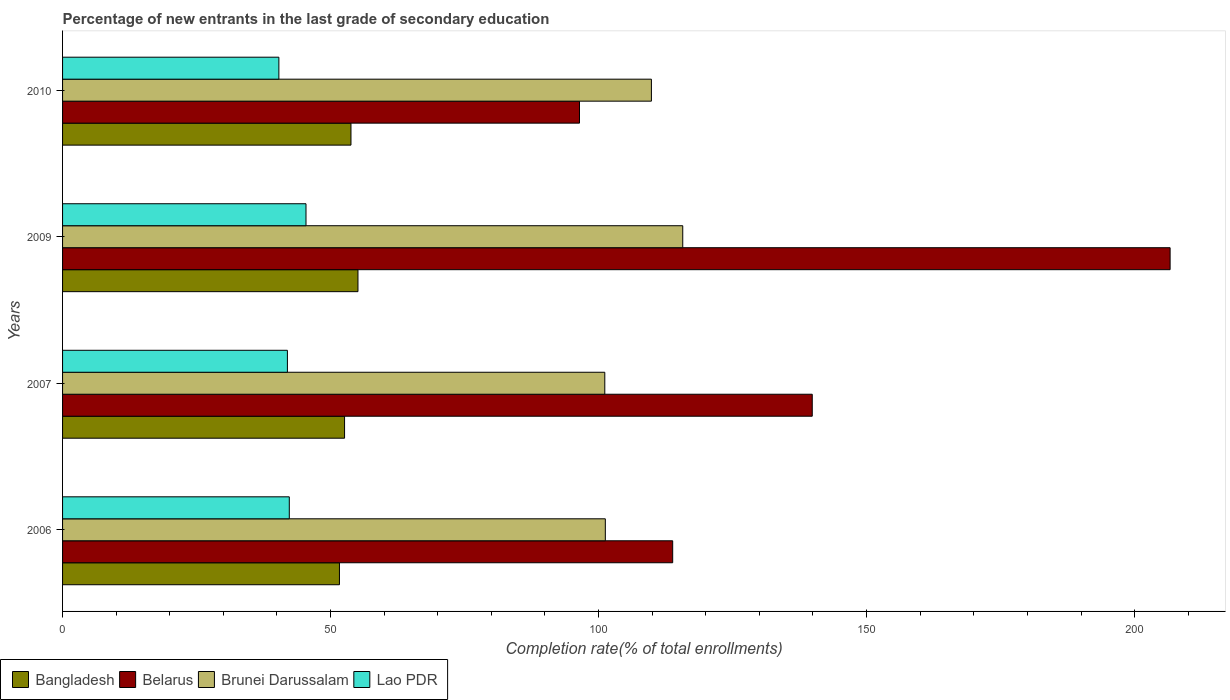Are the number of bars per tick equal to the number of legend labels?
Keep it short and to the point. Yes. What is the label of the 4th group of bars from the top?
Make the answer very short. 2006. What is the percentage of new entrants in Lao PDR in 2009?
Provide a succinct answer. 45.41. Across all years, what is the maximum percentage of new entrants in Belarus?
Provide a short and direct response. 206.63. Across all years, what is the minimum percentage of new entrants in Brunei Darussalam?
Your answer should be compact. 101.16. In which year was the percentage of new entrants in Bangladesh maximum?
Offer a terse response. 2009. In which year was the percentage of new entrants in Lao PDR minimum?
Your answer should be very brief. 2010. What is the total percentage of new entrants in Lao PDR in the graph?
Your answer should be very brief. 170.02. What is the difference between the percentage of new entrants in Bangladesh in 2007 and that in 2010?
Your response must be concise. -1.2. What is the difference between the percentage of new entrants in Brunei Darussalam in 2009 and the percentage of new entrants in Bangladesh in 2007?
Offer a terse response. 63.09. What is the average percentage of new entrants in Lao PDR per year?
Provide a succinct answer. 42.5. In the year 2009, what is the difference between the percentage of new entrants in Lao PDR and percentage of new entrants in Bangladesh?
Your answer should be very brief. -9.7. In how many years, is the percentage of new entrants in Bangladesh greater than 150 %?
Make the answer very short. 0. What is the ratio of the percentage of new entrants in Belarus in 2009 to that in 2010?
Your answer should be very brief. 2.14. Is the percentage of new entrants in Lao PDR in 2007 less than that in 2009?
Your answer should be very brief. Yes. Is the difference between the percentage of new entrants in Lao PDR in 2006 and 2007 greater than the difference between the percentage of new entrants in Bangladesh in 2006 and 2007?
Your response must be concise. Yes. What is the difference between the highest and the second highest percentage of new entrants in Bangladesh?
Provide a short and direct response. 1.3. What is the difference between the highest and the lowest percentage of new entrants in Belarus?
Provide a short and direct response. 110.19. Is it the case that in every year, the sum of the percentage of new entrants in Lao PDR and percentage of new entrants in Brunei Darussalam is greater than the sum of percentage of new entrants in Belarus and percentage of new entrants in Bangladesh?
Make the answer very short. Yes. What does the 2nd bar from the top in 2007 represents?
Offer a very short reply. Brunei Darussalam. What does the 1st bar from the bottom in 2010 represents?
Provide a short and direct response. Bangladesh. How many bars are there?
Offer a very short reply. 16. What is the difference between two consecutive major ticks on the X-axis?
Give a very brief answer. 50. Does the graph contain any zero values?
Offer a terse response. No. Does the graph contain grids?
Give a very brief answer. No. Where does the legend appear in the graph?
Give a very brief answer. Bottom left. How many legend labels are there?
Your response must be concise. 4. What is the title of the graph?
Provide a succinct answer. Percentage of new entrants in the last grade of secondary education. Does "Philippines" appear as one of the legend labels in the graph?
Ensure brevity in your answer.  No. What is the label or title of the X-axis?
Your answer should be very brief. Completion rate(% of total enrollments). What is the Completion rate(% of total enrollments) in Bangladesh in 2006?
Offer a terse response. 51.66. What is the Completion rate(% of total enrollments) of Belarus in 2006?
Ensure brevity in your answer.  113.82. What is the Completion rate(% of total enrollments) in Brunei Darussalam in 2006?
Your answer should be compact. 101.26. What is the Completion rate(% of total enrollments) of Lao PDR in 2006?
Offer a very short reply. 42.3. What is the Completion rate(% of total enrollments) of Bangladesh in 2007?
Your response must be concise. 52.61. What is the Completion rate(% of total enrollments) of Belarus in 2007?
Your response must be concise. 139.86. What is the Completion rate(% of total enrollments) in Brunei Darussalam in 2007?
Your answer should be compact. 101.16. What is the Completion rate(% of total enrollments) in Lao PDR in 2007?
Keep it short and to the point. 41.95. What is the Completion rate(% of total enrollments) of Bangladesh in 2009?
Provide a short and direct response. 55.11. What is the Completion rate(% of total enrollments) in Belarus in 2009?
Your response must be concise. 206.63. What is the Completion rate(% of total enrollments) of Brunei Darussalam in 2009?
Provide a succinct answer. 115.7. What is the Completion rate(% of total enrollments) in Lao PDR in 2009?
Provide a short and direct response. 45.41. What is the Completion rate(% of total enrollments) in Bangladesh in 2010?
Your answer should be compact. 53.81. What is the Completion rate(% of total enrollments) of Belarus in 2010?
Ensure brevity in your answer.  96.44. What is the Completion rate(% of total enrollments) of Brunei Darussalam in 2010?
Keep it short and to the point. 109.86. What is the Completion rate(% of total enrollments) in Lao PDR in 2010?
Give a very brief answer. 40.36. Across all years, what is the maximum Completion rate(% of total enrollments) in Bangladesh?
Offer a terse response. 55.11. Across all years, what is the maximum Completion rate(% of total enrollments) in Belarus?
Your answer should be very brief. 206.63. Across all years, what is the maximum Completion rate(% of total enrollments) of Brunei Darussalam?
Make the answer very short. 115.7. Across all years, what is the maximum Completion rate(% of total enrollments) in Lao PDR?
Offer a very short reply. 45.41. Across all years, what is the minimum Completion rate(% of total enrollments) in Bangladesh?
Your answer should be very brief. 51.66. Across all years, what is the minimum Completion rate(% of total enrollments) in Belarus?
Make the answer very short. 96.44. Across all years, what is the minimum Completion rate(% of total enrollments) in Brunei Darussalam?
Offer a very short reply. 101.16. Across all years, what is the minimum Completion rate(% of total enrollments) of Lao PDR?
Make the answer very short. 40.36. What is the total Completion rate(% of total enrollments) in Bangladesh in the graph?
Your answer should be very brief. 213.18. What is the total Completion rate(% of total enrollments) in Belarus in the graph?
Offer a very short reply. 556.75. What is the total Completion rate(% of total enrollments) of Brunei Darussalam in the graph?
Your answer should be compact. 427.97. What is the total Completion rate(% of total enrollments) of Lao PDR in the graph?
Provide a succinct answer. 170.02. What is the difference between the Completion rate(% of total enrollments) in Bangladesh in 2006 and that in 2007?
Offer a terse response. -0.95. What is the difference between the Completion rate(% of total enrollments) of Belarus in 2006 and that in 2007?
Make the answer very short. -26.04. What is the difference between the Completion rate(% of total enrollments) in Brunei Darussalam in 2006 and that in 2007?
Your answer should be very brief. 0.1. What is the difference between the Completion rate(% of total enrollments) of Lao PDR in 2006 and that in 2007?
Ensure brevity in your answer.  0.35. What is the difference between the Completion rate(% of total enrollments) in Bangladesh in 2006 and that in 2009?
Offer a terse response. -3.45. What is the difference between the Completion rate(% of total enrollments) in Belarus in 2006 and that in 2009?
Your answer should be very brief. -92.8. What is the difference between the Completion rate(% of total enrollments) in Brunei Darussalam in 2006 and that in 2009?
Your answer should be very brief. -14.44. What is the difference between the Completion rate(% of total enrollments) of Lao PDR in 2006 and that in 2009?
Provide a short and direct response. -3.11. What is the difference between the Completion rate(% of total enrollments) of Bangladesh in 2006 and that in 2010?
Ensure brevity in your answer.  -2.15. What is the difference between the Completion rate(% of total enrollments) of Belarus in 2006 and that in 2010?
Ensure brevity in your answer.  17.39. What is the difference between the Completion rate(% of total enrollments) in Brunei Darussalam in 2006 and that in 2010?
Give a very brief answer. -8.6. What is the difference between the Completion rate(% of total enrollments) in Lao PDR in 2006 and that in 2010?
Provide a succinct answer. 1.94. What is the difference between the Completion rate(% of total enrollments) of Bangladesh in 2007 and that in 2009?
Keep it short and to the point. -2.5. What is the difference between the Completion rate(% of total enrollments) of Belarus in 2007 and that in 2009?
Make the answer very short. -66.76. What is the difference between the Completion rate(% of total enrollments) of Brunei Darussalam in 2007 and that in 2009?
Provide a short and direct response. -14.54. What is the difference between the Completion rate(% of total enrollments) in Lao PDR in 2007 and that in 2009?
Your response must be concise. -3.47. What is the difference between the Completion rate(% of total enrollments) in Bangladesh in 2007 and that in 2010?
Ensure brevity in your answer.  -1.2. What is the difference between the Completion rate(% of total enrollments) in Belarus in 2007 and that in 2010?
Keep it short and to the point. 43.42. What is the difference between the Completion rate(% of total enrollments) in Brunei Darussalam in 2007 and that in 2010?
Your response must be concise. -8.7. What is the difference between the Completion rate(% of total enrollments) in Lao PDR in 2007 and that in 2010?
Your response must be concise. 1.59. What is the difference between the Completion rate(% of total enrollments) of Bangladesh in 2009 and that in 2010?
Give a very brief answer. 1.3. What is the difference between the Completion rate(% of total enrollments) of Belarus in 2009 and that in 2010?
Give a very brief answer. 110.19. What is the difference between the Completion rate(% of total enrollments) in Brunei Darussalam in 2009 and that in 2010?
Your answer should be very brief. 5.85. What is the difference between the Completion rate(% of total enrollments) of Lao PDR in 2009 and that in 2010?
Give a very brief answer. 5.06. What is the difference between the Completion rate(% of total enrollments) of Bangladesh in 2006 and the Completion rate(% of total enrollments) of Belarus in 2007?
Your response must be concise. -88.21. What is the difference between the Completion rate(% of total enrollments) of Bangladesh in 2006 and the Completion rate(% of total enrollments) of Brunei Darussalam in 2007?
Ensure brevity in your answer.  -49.5. What is the difference between the Completion rate(% of total enrollments) in Bangladesh in 2006 and the Completion rate(% of total enrollments) in Lao PDR in 2007?
Ensure brevity in your answer.  9.71. What is the difference between the Completion rate(% of total enrollments) of Belarus in 2006 and the Completion rate(% of total enrollments) of Brunei Darussalam in 2007?
Make the answer very short. 12.66. What is the difference between the Completion rate(% of total enrollments) in Belarus in 2006 and the Completion rate(% of total enrollments) in Lao PDR in 2007?
Give a very brief answer. 71.88. What is the difference between the Completion rate(% of total enrollments) in Brunei Darussalam in 2006 and the Completion rate(% of total enrollments) in Lao PDR in 2007?
Provide a short and direct response. 59.31. What is the difference between the Completion rate(% of total enrollments) of Bangladesh in 2006 and the Completion rate(% of total enrollments) of Belarus in 2009?
Offer a terse response. -154.97. What is the difference between the Completion rate(% of total enrollments) in Bangladesh in 2006 and the Completion rate(% of total enrollments) in Brunei Darussalam in 2009?
Your answer should be very brief. -64.05. What is the difference between the Completion rate(% of total enrollments) in Bangladesh in 2006 and the Completion rate(% of total enrollments) in Lao PDR in 2009?
Your answer should be very brief. 6.24. What is the difference between the Completion rate(% of total enrollments) of Belarus in 2006 and the Completion rate(% of total enrollments) of Brunei Darussalam in 2009?
Your answer should be very brief. -1.88. What is the difference between the Completion rate(% of total enrollments) in Belarus in 2006 and the Completion rate(% of total enrollments) in Lao PDR in 2009?
Offer a terse response. 68.41. What is the difference between the Completion rate(% of total enrollments) in Brunei Darussalam in 2006 and the Completion rate(% of total enrollments) in Lao PDR in 2009?
Give a very brief answer. 55.84. What is the difference between the Completion rate(% of total enrollments) in Bangladesh in 2006 and the Completion rate(% of total enrollments) in Belarus in 2010?
Make the answer very short. -44.78. What is the difference between the Completion rate(% of total enrollments) in Bangladesh in 2006 and the Completion rate(% of total enrollments) in Brunei Darussalam in 2010?
Provide a succinct answer. -58.2. What is the difference between the Completion rate(% of total enrollments) in Bangladesh in 2006 and the Completion rate(% of total enrollments) in Lao PDR in 2010?
Make the answer very short. 11.3. What is the difference between the Completion rate(% of total enrollments) of Belarus in 2006 and the Completion rate(% of total enrollments) of Brunei Darussalam in 2010?
Offer a terse response. 3.97. What is the difference between the Completion rate(% of total enrollments) in Belarus in 2006 and the Completion rate(% of total enrollments) in Lao PDR in 2010?
Offer a terse response. 73.47. What is the difference between the Completion rate(% of total enrollments) of Brunei Darussalam in 2006 and the Completion rate(% of total enrollments) of Lao PDR in 2010?
Keep it short and to the point. 60.9. What is the difference between the Completion rate(% of total enrollments) of Bangladesh in 2007 and the Completion rate(% of total enrollments) of Belarus in 2009?
Provide a short and direct response. -154.02. What is the difference between the Completion rate(% of total enrollments) of Bangladesh in 2007 and the Completion rate(% of total enrollments) of Brunei Darussalam in 2009?
Your response must be concise. -63.09. What is the difference between the Completion rate(% of total enrollments) of Bangladesh in 2007 and the Completion rate(% of total enrollments) of Lao PDR in 2009?
Make the answer very short. 7.19. What is the difference between the Completion rate(% of total enrollments) in Belarus in 2007 and the Completion rate(% of total enrollments) in Brunei Darussalam in 2009?
Ensure brevity in your answer.  24.16. What is the difference between the Completion rate(% of total enrollments) of Belarus in 2007 and the Completion rate(% of total enrollments) of Lao PDR in 2009?
Keep it short and to the point. 94.45. What is the difference between the Completion rate(% of total enrollments) of Brunei Darussalam in 2007 and the Completion rate(% of total enrollments) of Lao PDR in 2009?
Make the answer very short. 55.74. What is the difference between the Completion rate(% of total enrollments) of Bangladesh in 2007 and the Completion rate(% of total enrollments) of Belarus in 2010?
Provide a succinct answer. -43.83. What is the difference between the Completion rate(% of total enrollments) in Bangladesh in 2007 and the Completion rate(% of total enrollments) in Brunei Darussalam in 2010?
Your response must be concise. -57.25. What is the difference between the Completion rate(% of total enrollments) of Bangladesh in 2007 and the Completion rate(% of total enrollments) of Lao PDR in 2010?
Make the answer very short. 12.25. What is the difference between the Completion rate(% of total enrollments) in Belarus in 2007 and the Completion rate(% of total enrollments) in Brunei Darussalam in 2010?
Offer a very short reply. 30.01. What is the difference between the Completion rate(% of total enrollments) in Belarus in 2007 and the Completion rate(% of total enrollments) in Lao PDR in 2010?
Offer a terse response. 99.51. What is the difference between the Completion rate(% of total enrollments) in Brunei Darussalam in 2007 and the Completion rate(% of total enrollments) in Lao PDR in 2010?
Provide a short and direct response. 60.8. What is the difference between the Completion rate(% of total enrollments) in Bangladesh in 2009 and the Completion rate(% of total enrollments) in Belarus in 2010?
Your response must be concise. -41.33. What is the difference between the Completion rate(% of total enrollments) of Bangladesh in 2009 and the Completion rate(% of total enrollments) of Brunei Darussalam in 2010?
Provide a short and direct response. -54.75. What is the difference between the Completion rate(% of total enrollments) in Bangladesh in 2009 and the Completion rate(% of total enrollments) in Lao PDR in 2010?
Offer a very short reply. 14.75. What is the difference between the Completion rate(% of total enrollments) of Belarus in 2009 and the Completion rate(% of total enrollments) of Brunei Darussalam in 2010?
Give a very brief answer. 96.77. What is the difference between the Completion rate(% of total enrollments) of Belarus in 2009 and the Completion rate(% of total enrollments) of Lao PDR in 2010?
Offer a very short reply. 166.27. What is the difference between the Completion rate(% of total enrollments) in Brunei Darussalam in 2009 and the Completion rate(% of total enrollments) in Lao PDR in 2010?
Offer a terse response. 75.35. What is the average Completion rate(% of total enrollments) in Bangladesh per year?
Keep it short and to the point. 53.3. What is the average Completion rate(% of total enrollments) in Belarus per year?
Your response must be concise. 139.19. What is the average Completion rate(% of total enrollments) of Brunei Darussalam per year?
Offer a very short reply. 106.99. What is the average Completion rate(% of total enrollments) of Lao PDR per year?
Offer a terse response. 42.5. In the year 2006, what is the difference between the Completion rate(% of total enrollments) of Bangladesh and Completion rate(% of total enrollments) of Belarus?
Keep it short and to the point. -62.17. In the year 2006, what is the difference between the Completion rate(% of total enrollments) of Bangladesh and Completion rate(% of total enrollments) of Brunei Darussalam?
Your response must be concise. -49.6. In the year 2006, what is the difference between the Completion rate(% of total enrollments) in Bangladesh and Completion rate(% of total enrollments) in Lao PDR?
Make the answer very short. 9.36. In the year 2006, what is the difference between the Completion rate(% of total enrollments) of Belarus and Completion rate(% of total enrollments) of Brunei Darussalam?
Offer a terse response. 12.57. In the year 2006, what is the difference between the Completion rate(% of total enrollments) of Belarus and Completion rate(% of total enrollments) of Lao PDR?
Your answer should be compact. 71.52. In the year 2006, what is the difference between the Completion rate(% of total enrollments) in Brunei Darussalam and Completion rate(% of total enrollments) in Lao PDR?
Keep it short and to the point. 58.96. In the year 2007, what is the difference between the Completion rate(% of total enrollments) in Bangladesh and Completion rate(% of total enrollments) in Belarus?
Make the answer very short. -87.25. In the year 2007, what is the difference between the Completion rate(% of total enrollments) of Bangladesh and Completion rate(% of total enrollments) of Brunei Darussalam?
Your answer should be compact. -48.55. In the year 2007, what is the difference between the Completion rate(% of total enrollments) in Bangladesh and Completion rate(% of total enrollments) in Lao PDR?
Make the answer very short. 10.66. In the year 2007, what is the difference between the Completion rate(% of total enrollments) of Belarus and Completion rate(% of total enrollments) of Brunei Darussalam?
Provide a succinct answer. 38.7. In the year 2007, what is the difference between the Completion rate(% of total enrollments) of Belarus and Completion rate(% of total enrollments) of Lao PDR?
Provide a succinct answer. 97.92. In the year 2007, what is the difference between the Completion rate(% of total enrollments) in Brunei Darussalam and Completion rate(% of total enrollments) in Lao PDR?
Give a very brief answer. 59.21. In the year 2009, what is the difference between the Completion rate(% of total enrollments) in Bangladesh and Completion rate(% of total enrollments) in Belarus?
Offer a terse response. -151.52. In the year 2009, what is the difference between the Completion rate(% of total enrollments) in Bangladesh and Completion rate(% of total enrollments) in Brunei Darussalam?
Ensure brevity in your answer.  -60.59. In the year 2009, what is the difference between the Completion rate(% of total enrollments) in Bangladesh and Completion rate(% of total enrollments) in Lao PDR?
Your response must be concise. 9.7. In the year 2009, what is the difference between the Completion rate(% of total enrollments) in Belarus and Completion rate(% of total enrollments) in Brunei Darussalam?
Give a very brief answer. 90.92. In the year 2009, what is the difference between the Completion rate(% of total enrollments) of Belarus and Completion rate(% of total enrollments) of Lao PDR?
Keep it short and to the point. 161.21. In the year 2009, what is the difference between the Completion rate(% of total enrollments) in Brunei Darussalam and Completion rate(% of total enrollments) in Lao PDR?
Ensure brevity in your answer.  70.29. In the year 2010, what is the difference between the Completion rate(% of total enrollments) in Bangladesh and Completion rate(% of total enrollments) in Belarus?
Your answer should be very brief. -42.63. In the year 2010, what is the difference between the Completion rate(% of total enrollments) in Bangladesh and Completion rate(% of total enrollments) in Brunei Darussalam?
Make the answer very short. -56.05. In the year 2010, what is the difference between the Completion rate(% of total enrollments) in Bangladesh and Completion rate(% of total enrollments) in Lao PDR?
Offer a terse response. 13.45. In the year 2010, what is the difference between the Completion rate(% of total enrollments) in Belarus and Completion rate(% of total enrollments) in Brunei Darussalam?
Your answer should be compact. -13.42. In the year 2010, what is the difference between the Completion rate(% of total enrollments) of Belarus and Completion rate(% of total enrollments) of Lao PDR?
Your response must be concise. 56.08. In the year 2010, what is the difference between the Completion rate(% of total enrollments) of Brunei Darussalam and Completion rate(% of total enrollments) of Lao PDR?
Give a very brief answer. 69.5. What is the ratio of the Completion rate(% of total enrollments) in Bangladesh in 2006 to that in 2007?
Give a very brief answer. 0.98. What is the ratio of the Completion rate(% of total enrollments) of Belarus in 2006 to that in 2007?
Offer a terse response. 0.81. What is the ratio of the Completion rate(% of total enrollments) of Lao PDR in 2006 to that in 2007?
Make the answer very short. 1.01. What is the ratio of the Completion rate(% of total enrollments) of Bangladesh in 2006 to that in 2009?
Keep it short and to the point. 0.94. What is the ratio of the Completion rate(% of total enrollments) of Belarus in 2006 to that in 2009?
Offer a terse response. 0.55. What is the ratio of the Completion rate(% of total enrollments) of Brunei Darussalam in 2006 to that in 2009?
Your answer should be very brief. 0.88. What is the ratio of the Completion rate(% of total enrollments) in Lao PDR in 2006 to that in 2009?
Offer a very short reply. 0.93. What is the ratio of the Completion rate(% of total enrollments) in Bangladesh in 2006 to that in 2010?
Provide a short and direct response. 0.96. What is the ratio of the Completion rate(% of total enrollments) of Belarus in 2006 to that in 2010?
Keep it short and to the point. 1.18. What is the ratio of the Completion rate(% of total enrollments) of Brunei Darussalam in 2006 to that in 2010?
Ensure brevity in your answer.  0.92. What is the ratio of the Completion rate(% of total enrollments) in Lao PDR in 2006 to that in 2010?
Ensure brevity in your answer.  1.05. What is the ratio of the Completion rate(% of total enrollments) of Bangladesh in 2007 to that in 2009?
Ensure brevity in your answer.  0.95. What is the ratio of the Completion rate(% of total enrollments) of Belarus in 2007 to that in 2009?
Ensure brevity in your answer.  0.68. What is the ratio of the Completion rate(% of total enrollments) of Brunei Darussalam in 2007 to that in 2009?
Ensure brevity in your answer.  0.87. What is the ratio of the Completion rate(% of total enrollments) of Lao PDR in 2007 to that in 2009?
Give a very brief answer. 0.92. What is the ratio of the Completion rate(% of total enrollments) in Bangladesh in 2007 to that in 2010?
Your answer should be compact. 0.98. What is the ratio of the Completion rate(% of total enrollments) of Belarus in 2007 to that in 2010?
Ensure brevity in your answer.  1.45. What is the ratio of the Completion rate(% of total enrollments) in Brunei Darussalam in 2007 to that in 2010?
Ensure brevity in your answer.  0.92. What is the ratio of the Completion rate(% of total enrollments) in Lao PDR in 2007 to that in 2010?
Give a very brief answer. 1.04. What is the ratio of the Completion rate(% of total enrollments) in Bangladesh in 2009 to that in 2010?
Keep it short and to the point. 1.02. What is the ratio of the Completion rate(% of total enrollments) in Belarus in 2009 to that in 2010?
Your response must be concise. 2.14. What is the ratio of the Completion rate(% of total enrollments) of Brunei Darussalam in 2009 to that in 2010?
Provide a succinct answer. 1.05. What is the ratio of the Completion rate(% of total enrollments) in Lao PDR in 2009 to that in 2010?
Ensure brevity in your answer.  1.13. What is the difference between the highest and the second highest Completion rate(% of total enrollments) in Bangladesh?
Provide a short and direct response. 1.3. What is the difference between the highest and the second highest Completion rate(% of total enrollments) of Belarus?
Provide a succinct answer. 66.76. What is the difference between the highest and the second highest Completion rate(% of total enrollments) in Brunei Darussalam?
Keep it short and to the point. 5.85. What is the difference between the highest and the second highest Completion rate(% of total enrollments) of Lao PDR?
Give a very brief answer. 3.11. What is the difference between the highest and the lowest Completion rate(% of total enrollments) in Bangladesh?
Keep it short and to the point. 3.45. What is the difference between the highest and the lowest Completion rate(% of total enrollments) in Belarus?
Your response must be concise. 110.19. What is the difference between the highest and the lowest Completion rate(% of total enrollments) of Brunei Darussalam?
Give a very brief answer. 14.54. What is the difference between the highest and the lowest Completion rate(% of total enrollments) of Lao PDR?
Provide a short and direct response. 5.06. 